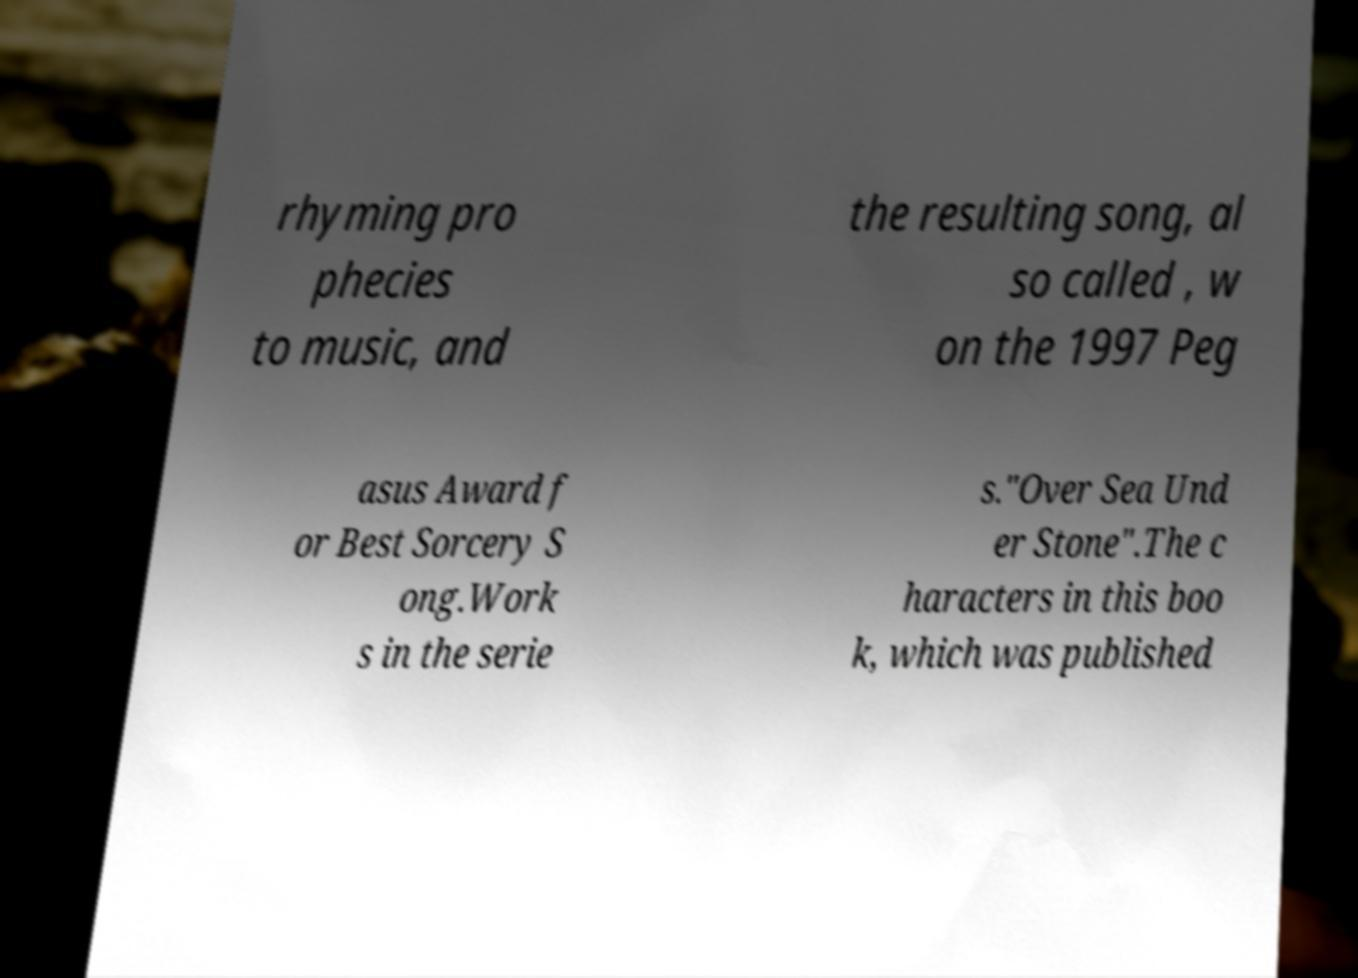Can you accurately transcribe the text from the provided image for me? rhyming pro phecies to music, and the resulting song, al so called , w on the 1997 Peg asus Award f or Best Sorcery S ong.Work s in the serie s."Over Sea Und er Stone".The c haracters in this boo k, which was published 